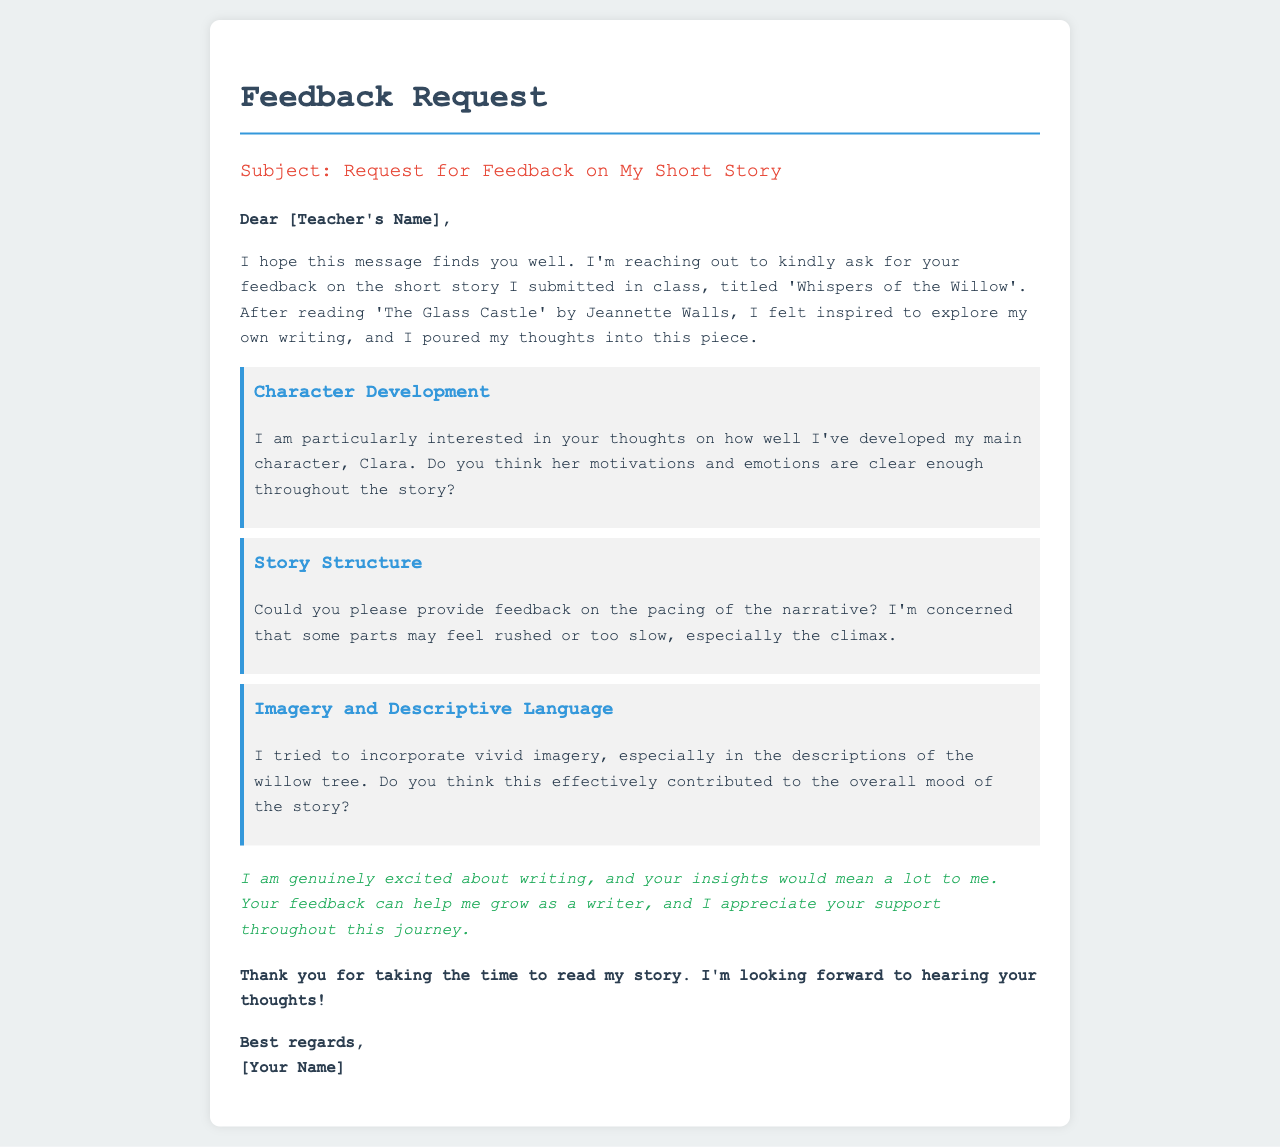What is the title of the short story? The title of the short story is mentioned in the greeting section where it says 'titled 'Whispers of the Willow'.'
Answer: Whispers of the Willow Who is the author of the short story? The author is indicated at the end of the email where it says '[Your Name]'.
Answer: [Your Name] What is the main character's name? The main character's name is mentioned in the character development section as 'Clara'.
Answer: Clara Which book inspired the author to write this story? The book that inspired the author is mentioned in the introduction, it states 'After reading 'The Glass Castle' by Jeannette Walls.'
Answer: The Glass Castle What specific area of feedback is requested regarding the narrative? The author specifically asks for feedback on the pacing of the narrative in the story structure section.
Answer: Pacing What aspect of imagery is the author particularly interested in? The author is interested in the effective contribution of imagery to the overall mood of the story, specifically in the descriptions of the willow tree.
Answer: Descriptions of the willow tree What is the tone of the author's request for feedback? The tone can be surmised from the email content, which expresses genuine excitement and appreciation for support throughout their writing journey.
Answer: Encouraging What is the main purpose of this email? The main purpose of the email is to request feedback on the author's short story.
Answer: Request for feedback What type of language does the author use in their writing? The author mentions they tried to incorporate 'vivid imagery' in their writing.
Answer: Vivid imagery 